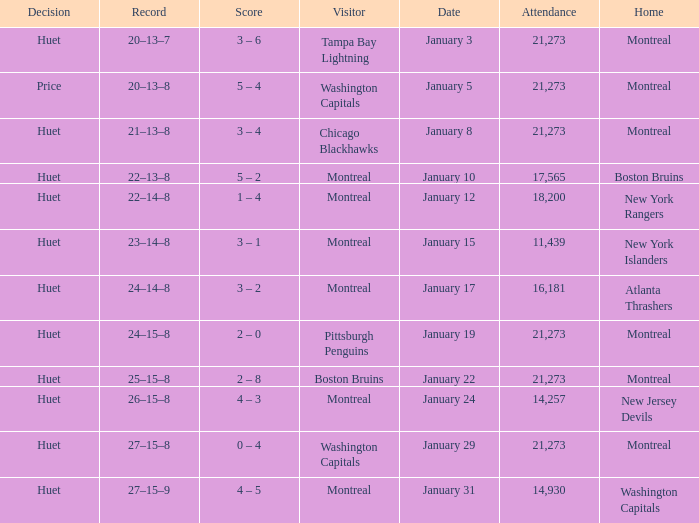What was the score of the game when the Boston Bruins were the visiting team? 2 – 8. 